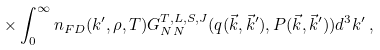Convert formula to latex. <formula><loc_0><loc_0><loc_500><loc_500>\times \int _ { 0 } ^ { \infty } n _ { F D } ( k ^ { \prime } , \rho , T ) G ^ { T , L , S , J } _ { N N } ( q ( { \vec { k } } , { \vec { k } ^ { \prime } } ) , P ( { \vec { k } } , { \vec { k } ^ { \prime } } ) ) d ^ { 3 } k ^ { \prime } \, ,</formula> 